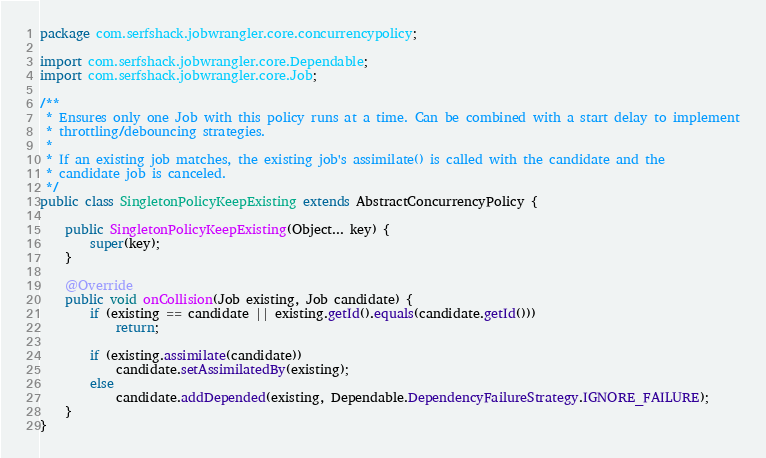<code> <loc_0><loc_0><loc_500><loc_500><_Java_>package com.serfshack.jobwrangler.core.concurrencypolicy;

import com.serfshack.jobwrangler.core.Dependable;
import com.serfshack.jobwrangler.core.Job;

/**
 * Ensures only one Job with this policy runs at a time. Can be combined with a start delay to implement
 * throttling/debouncing strategies.
 *
 * If an existing job matches, the existing job's assimilate() is called with the candidate and the
 * candidate job is canceled.
 */
public class SingletonPolicyKeepExisting extends AbstractConcurrencyPolicy {

    public SingletonPolicyKeepExisting(Object... key) {
        super(key);
    }

    @Override
    public void onCollision(Job existing, Job candidate) {
        if (existing == candidate || existing.getId().equals(candidate.getId()))
            return;

        if (existing.assimilate(candidate))
            candidate.setAssimilatedBy(existing);
        else
            candidate.addDepended(existing, Dependable.DependencyFailureStrategy.IGNORE_FAILURE);
    }
}
</code> 